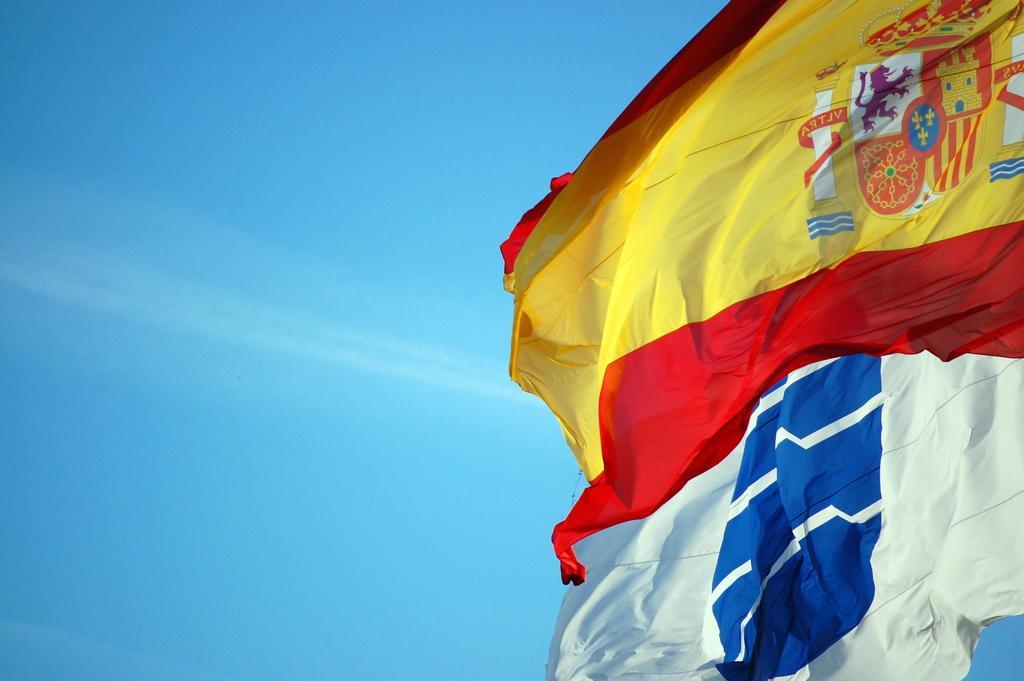Describe this image in one or two sentences. In this picture we can see two flags and logos on a flag and in the background we can see the sky. 